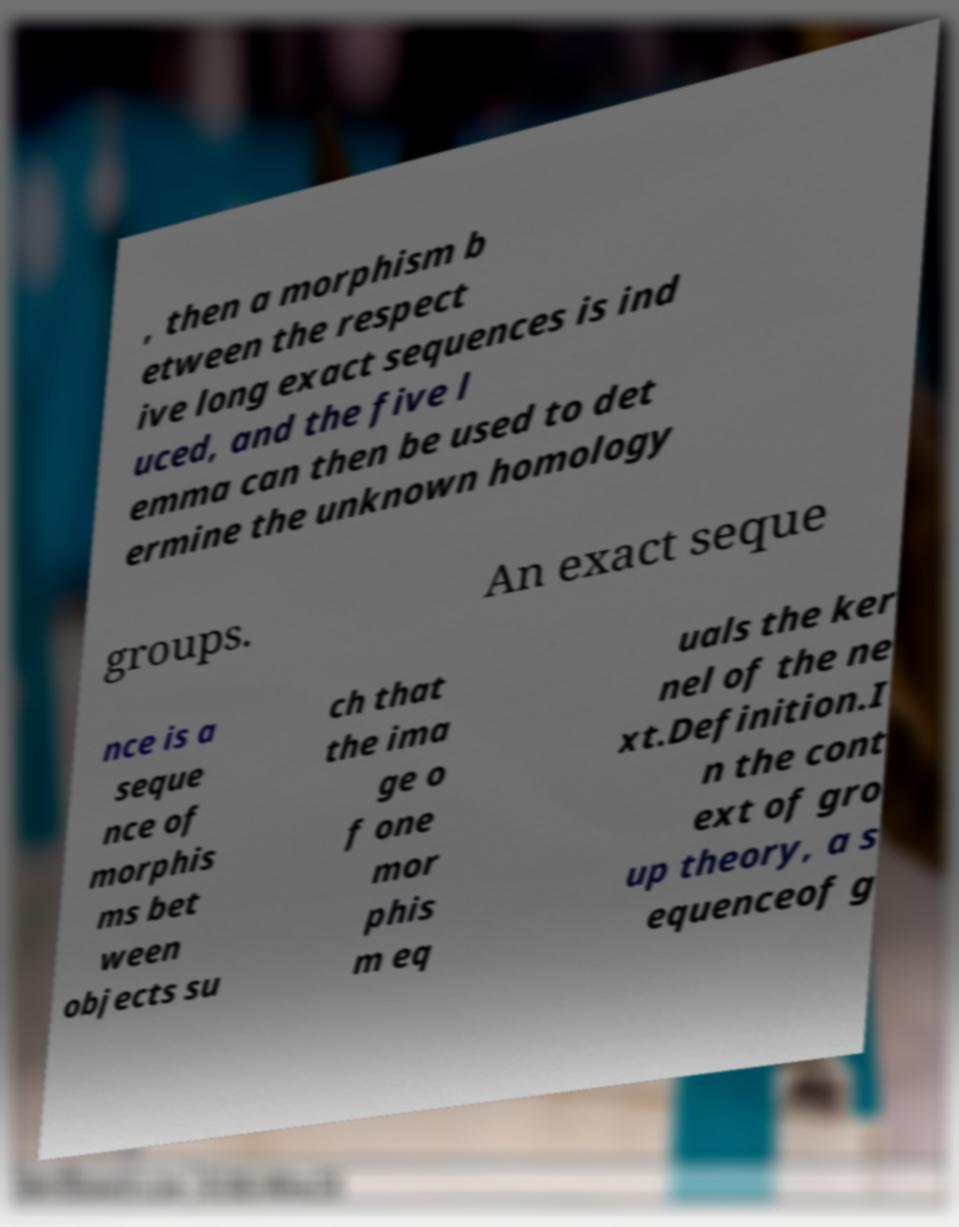Please identify and transcribe the text found in this image. , then a morphism b etween the respect ive long exact sequences is ind uced, and the five l emma can then be used to det ermine the unknown homology groups. An exact seque nce is a seque nce of morphis ms bet ween objects su ch that the ima ge o f one mor phis m eq uals the ker nel of the ne xt.Definition.I n the cont ext of gro up theory, a s equenceof g 